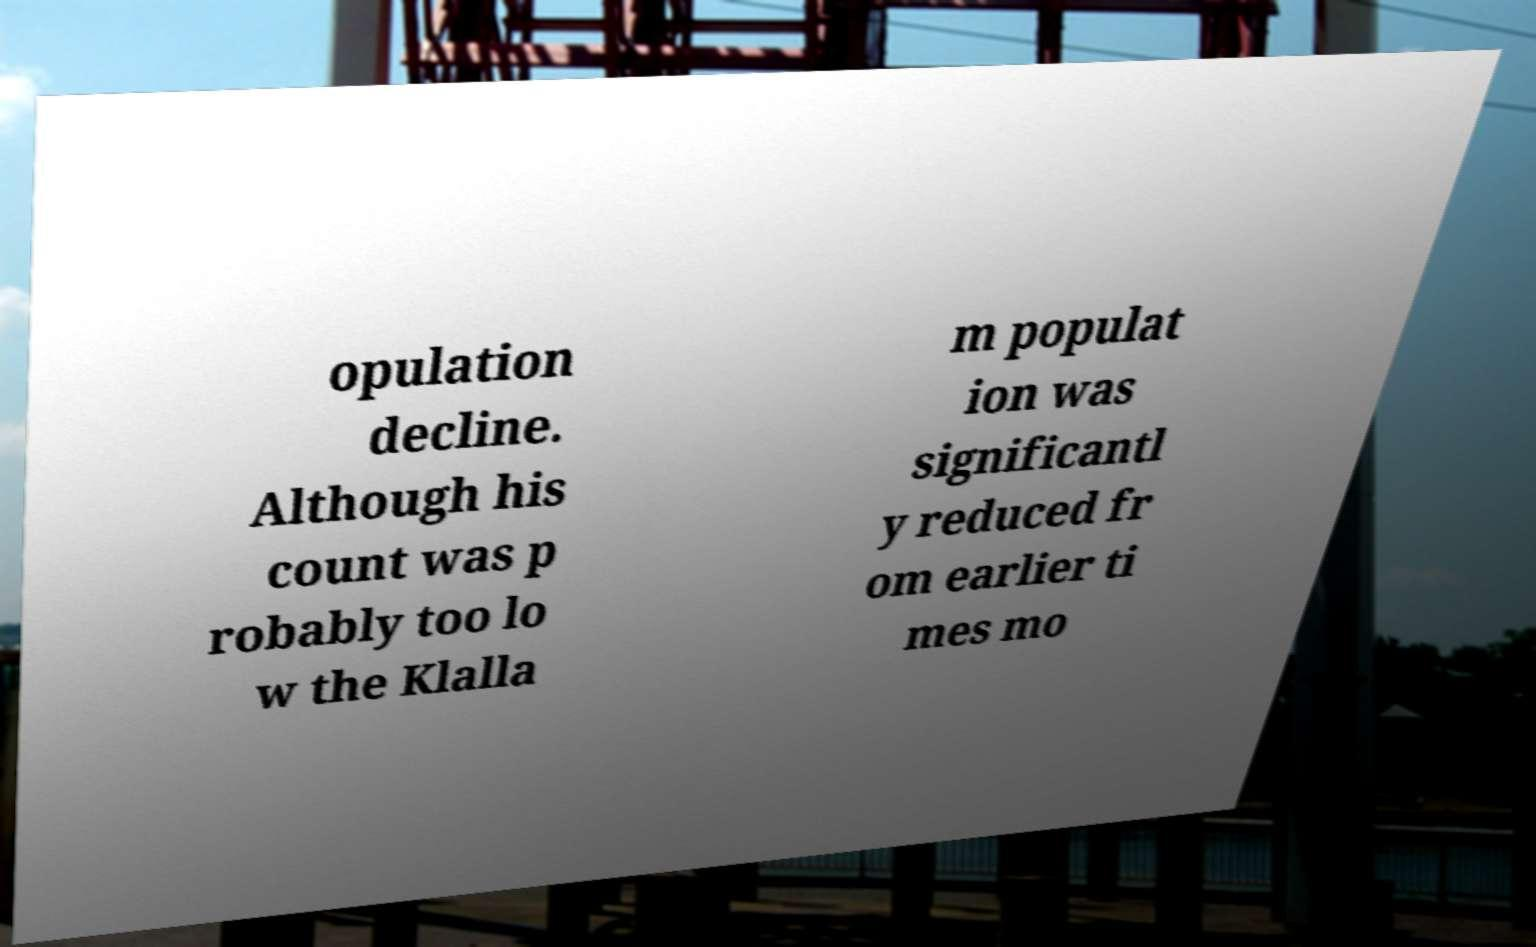There's text embedded in this image that I need extracted. Can you transcribe it verbatim? opulation decline. Although his count was p robably too lo w the Klalla m populat ion was significantl y reduced fr om earlier ti mes mo 